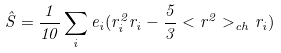Convert formula to latex. <formula><loc_0><loc_0><loc_500><loc_500>\hat { S } = \frac { 1 } { 1 0 } \sum _ { i } e _ { i } ( r _ { i } ^ { 2 } { r } _ { i } - \frac { 5 } { 3 } < r ^ { 2 } > _ { c h } { r } _ { i } )</formula> 